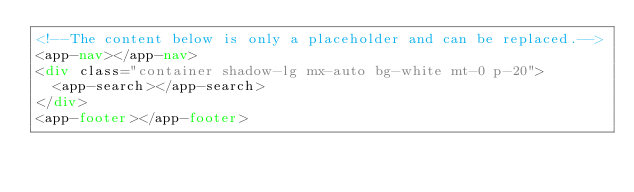Convert code to text. <code><loc_0><loc_0><loc_500><loc_500><_HTML_><!--The content below is only a placeholder and can be replaced.-->
<app-nav></app-nav>
<div class="container shadow-lg mx-auto bg-white mt-0 p-20">
  <app-search></app-search>
</div>
<app-footer></app-footer>
</code> 